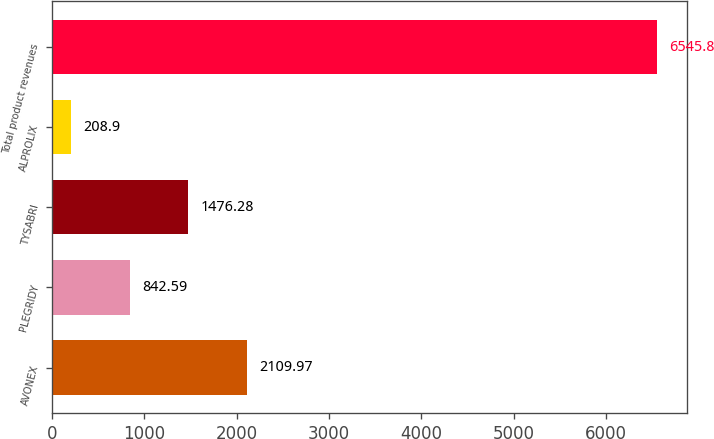<chart> <loc_0><loc_0><loc_500><loc_500><bar_chart><fcel>AVONEX<fcel>PLEGRIDY<fcel>TYSABRI<fcel>ALPROLIX<fcel>Total product revenues<nl><fcel>2109.97<fcel>842.59<fcel>1476.28<fcel>208.9<fcel>6545.8<nl></chart> 